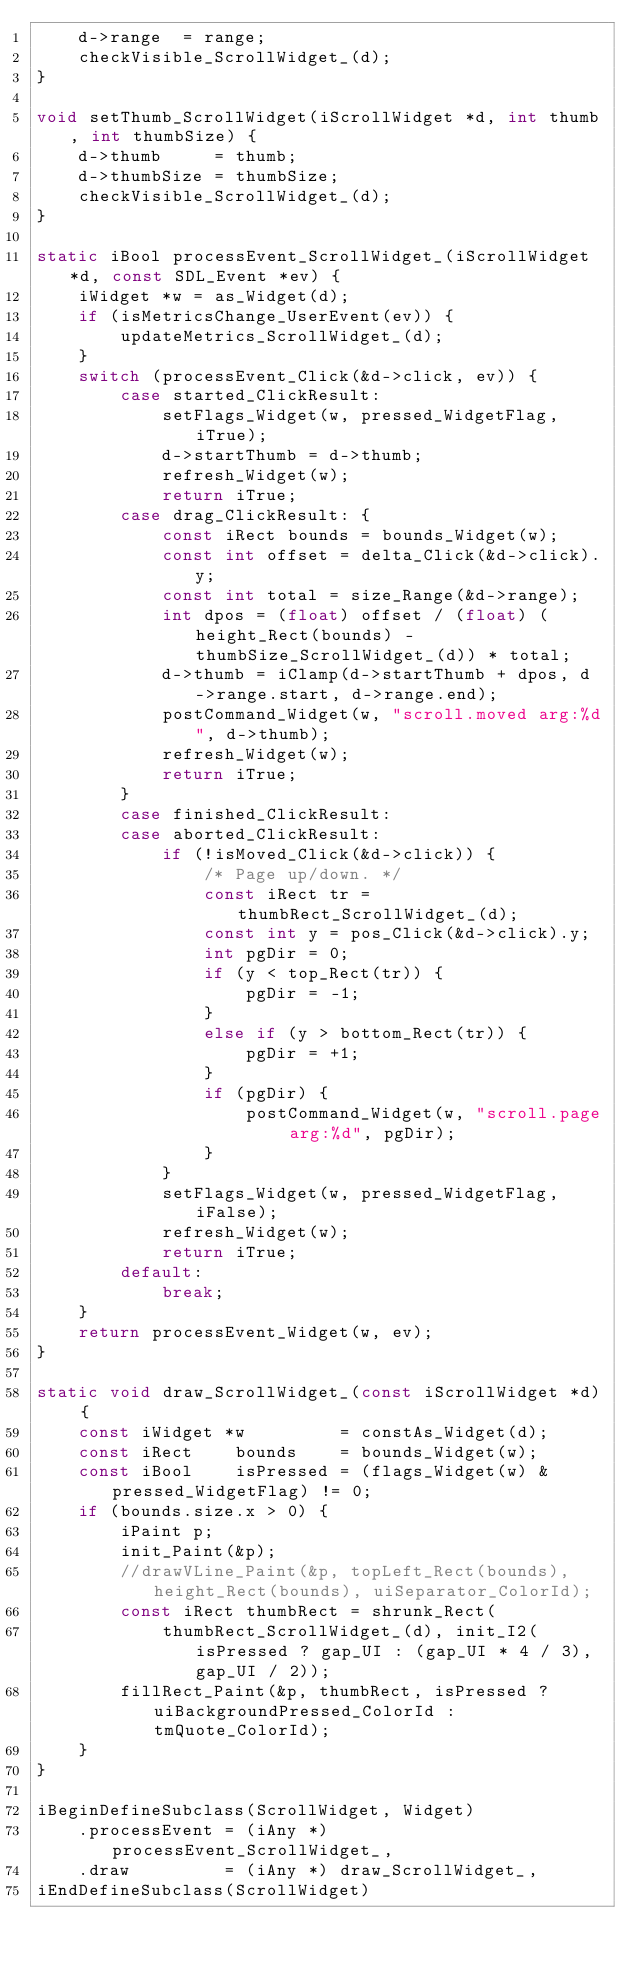<code> <loc_0><loc_0><loc_500><loc_500><_C_>    d->range  = range;
    checkVisible_ScrollWidget_(d);
}

void setThumb_ScrollWidget(iScrollWidget *d, int thumb, int thumbSize) {
    d->thumb     = thumb;
    d->thumbSize = thumbSize;
    checkVisible_ScrollWidget_(d);
}

static iBool processEvent_ScrollWidget_(iScrollWidget *d, const SDL_Event *ev) {
    iWidget *w = as_Widget(d);
    if (isMetricsChange_UserEvent(ev)) {
        updateMetrics_ScrollWidget_(d);
    }
    switch (processEvent_Click(&d->click, ev)) {
        case started_ClickResult:
            setFlags_Widget(w, pressed_WidgetFlag, iTrue);
            d->startThumb = d->thumb;
            refresh_Widget(w);
            return iTrue;
        case drag_ClickResult: {
            const iRect bounds = bounds_Widget(w);
            const int offset = delta_Click(&d->click).y;
            const int total = size_Range(&d->range);
            int dpos = (float) offset / (float) (height_Rect(bounds) - thumbSize_ScrollWidget_(d)) * total;
            d->thumb = iClamp(d->startThumb + dpos, d->range.start, d->range.end);
            postCommand_Widget(w, "scroll.moved arg:%d", d->thumb);
            refresh_Widget(w);
            return iTrue;
        }
        case finished_ClickResult:
        case aborted_ClickResult:
            if (!isMoved_Click(&d->click)) {
                /* Page up/down. */
                const iRect tr = thumbRect_ScrollWidget_(d);
                const int y = pos_Click(&d->click).y;
                int pgDir = 0;
                if (y < top_Rect(tr)) {
                    pgDir = -1;
                }
                else if (y > bottom_Rect(tr)) {
                    pgDir = +1;
                }
                if (pgDir) {
                    postCommand_Widget(w, "scroll.page arg:%d", pgDir);
                }
            }
            setFlags_Widget(w, pressed_WidgetFlag, iFalse);
            refresh_Widget(w);
            return iTrue;
        default:
            break;
    }
    return processEvent_Widget(w, ev);
}

static void draw_ScrollWidget_(const iScrollWidget *d) {
    const iWidget *w         = constAs_Widget(d);
    const iRect    bounds    = bounds_Widget(w);
    const iBool    isPressed = (flags_Widget(w) & pressed_WidgetFlag) != 0;
    if (bounds.size.x > 0) {
        iPaint p;
        init_Paint(&p);
        //drawVLine_Paint(&p, topLeft_Rect(bounds), height_Rect(bounds), uiSeparator_ColorId);
        const iRect thumbRect = shrunk_Rect(
            thumbRect_ScrollWidget_(d), init_I2(isPressed ? gap_UI : (gap_UI * 4 / 3), gap_UI / 2));
        fillRect_Paint(&p, thumbRect, isPressed ? uiBackgroundPressed_ColorId : tmQuote_ColorId);
    }
}

iBeginDefineSubclass(ScrollWidget, Widget)
    .processEvent = (iAny *) processEvent_ScrollWidget_,
    .draw         = (iAny *) draw_ScrollWidget_,
iEndDefineSubclass(ScrollWidget)
</code> 